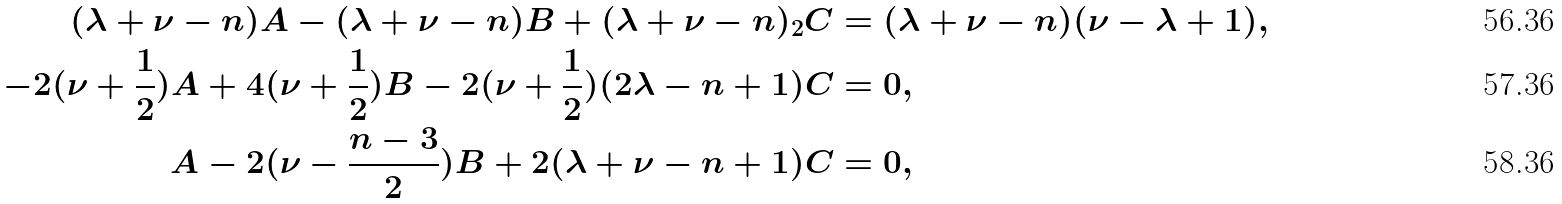Convert formula to latex. <formula><loc_0><loc_0><loc_500><loc_500>( \lambda + \nu - n ) A - ( \lambda + \nu - n ) B + ( \lambda + \nu - n ) _ { 2 } C & = ( \lambda + \nu - n ) ( \nu - \lambda + 1 ) , \\ - 2 ( \nu + \frac { 1 } { 2 } ) A + 4 ( \nu + \frac { 1 } { 2 } ) B - 2 ( \nu + \frac { 1 } { 2 } ) ( 2 \lambda - n + 1 ) C & = 0 , \\ A - 2 ( \nu - \frac { n - 3 } { 2 } ) B + 2 ( \lambda + \nu - n + 1 ) C & = 0 ,</formula> 